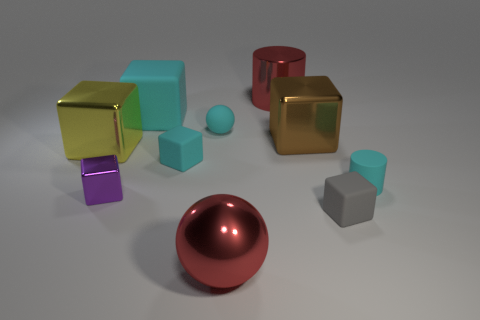Subtract all cyan cubes. How many were subtracted if there are1cyan cubes left? 1 Subtract all brown cubes. How many cubes are left? 5 Subtract all big metal cubes. How many cubes are left? 4 Subtract all cubes. How many objects are left? 4 Add 2 small cyan objects. How many small cyan objects are left? 5 Add 1 big cyan objects. How many big cyan objects exist? 2 Subtract 1 cyan cylinders. How many objects are left? 9 Subtract 2 blocks. How many blocks are left? 4 Subtract all red balls. Subtract all yellow cubes. How many balls are left? 1 Subtract all purple blocks. How many blue spheres are left? 0 